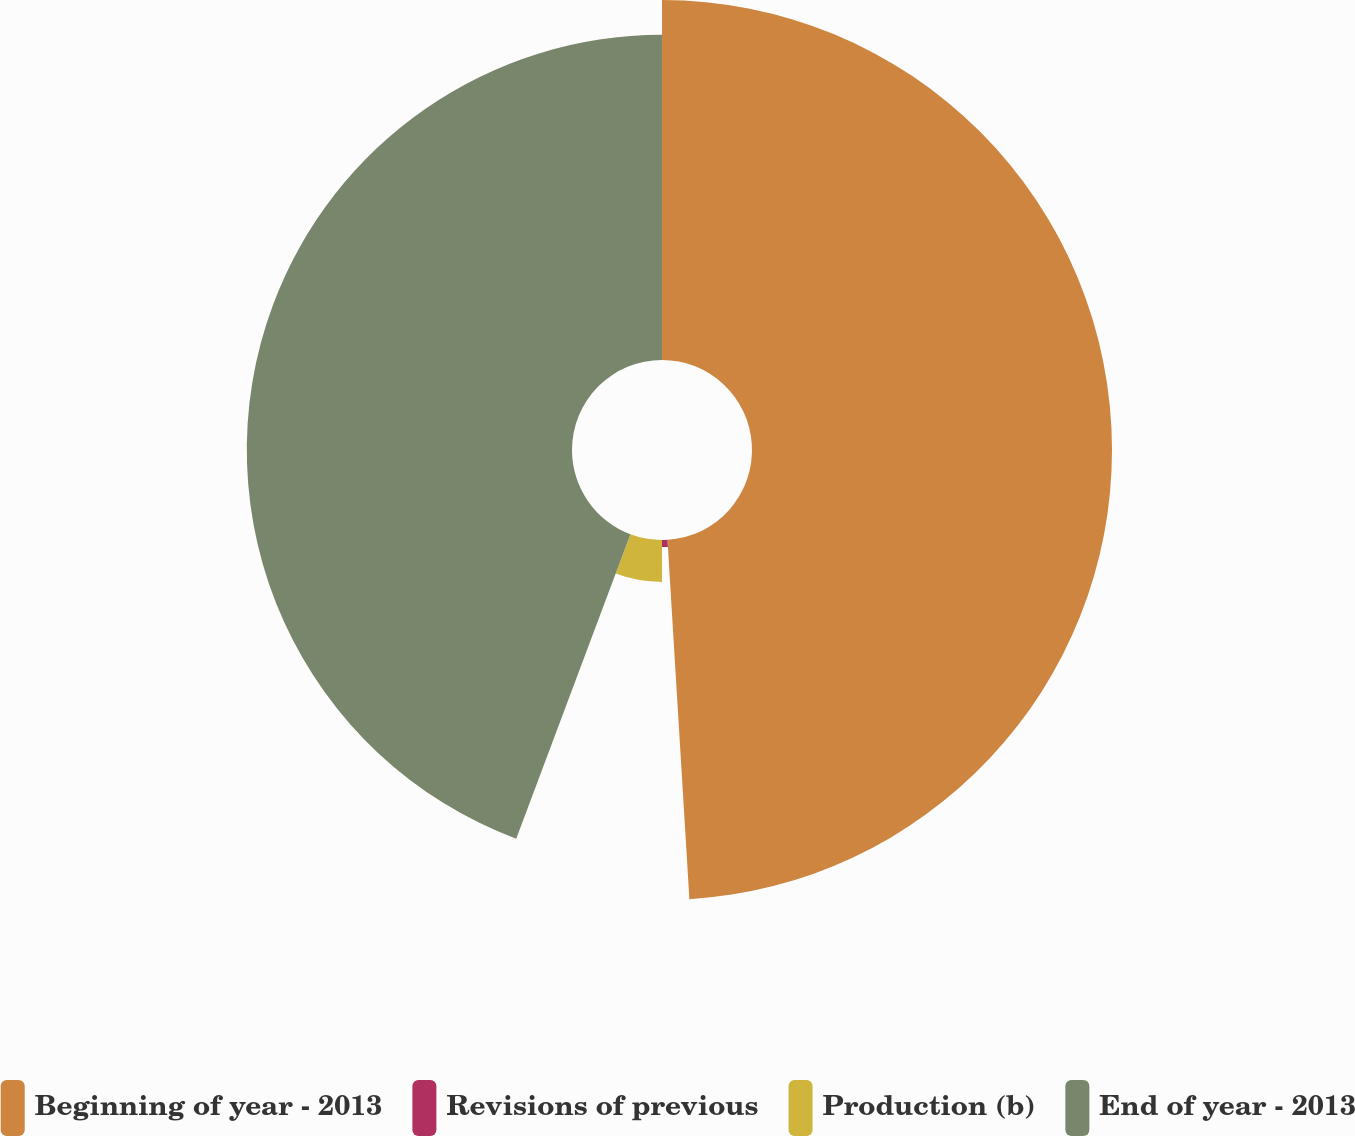Convert chart. <chart><loc_0><loc_0><loc_500><loc_500><pie_chart><fcel>Beginning of year - 2013<fcel>Revisions of previous<fcel>Production (b)<fcel>End of year - 2013<nl><fcel>49.03%<fcel>0.97%<fcel>5.71%<fcel>44.29%<nl></chart> 